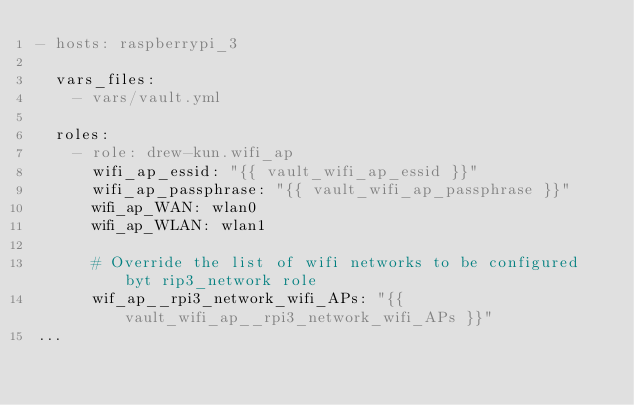Convert code to text. <code><loc_0><loc_0><loc_500><loc_500><_YAML_>- hosts: raspberrypi_3

  vars_files:
    - vars/vault.yml

  roles:
    - role: drew-kun.wifi_ap
      wifi_ap_essid: "{{ vault_wifi_ap_essid }}"
      wifi_ap_passphrase: "{{ vault_wifi_ap_passphrase }}"
      wifi_ap_WAN: wlan0
      wifi_ap_WLAN: wlan1

      # Override the list of wifi networks to be configured byt rip3_network role
      wif_ap__rpi3_network_wifi_APs: "{{  vault_wifi_ap__rpi3_network_wifi_APs }}"
...
</code> 